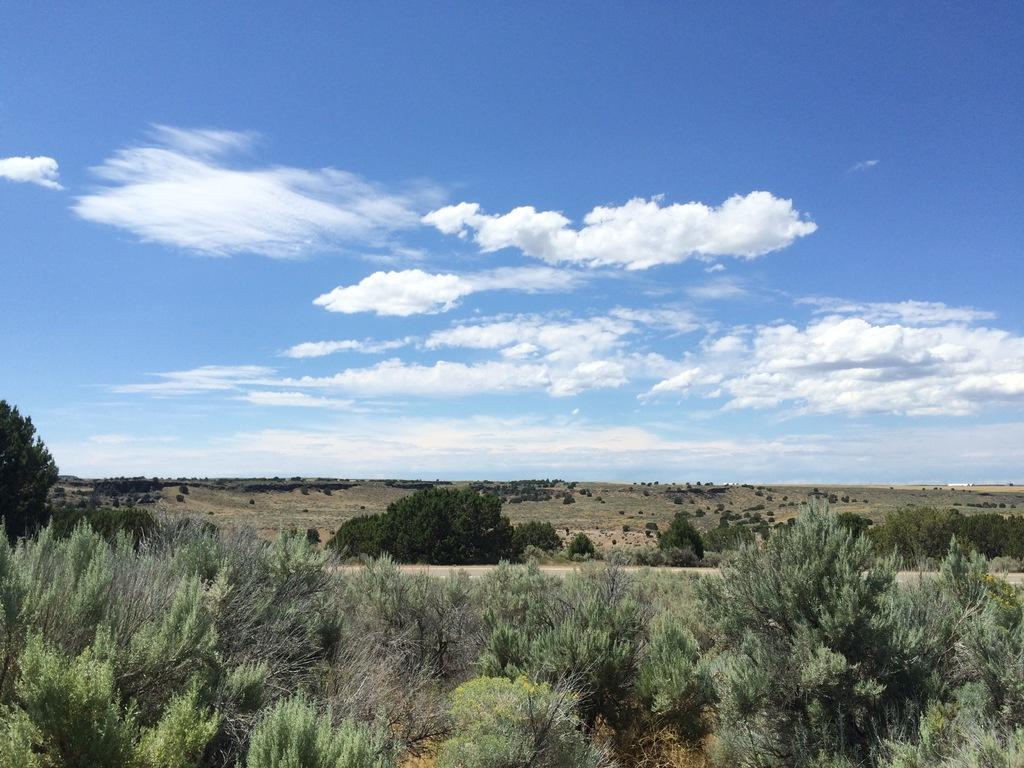What type of vegetation can be seen in the image? There are trees and plants in the image. Can you describe the sky in the image? The sky is blue and white in color. What disease is affecting the plants in the image? There is no indication of any disease affecting the plants in the image. What type of support can be seen in the image? There is no support structure visible in the image. 